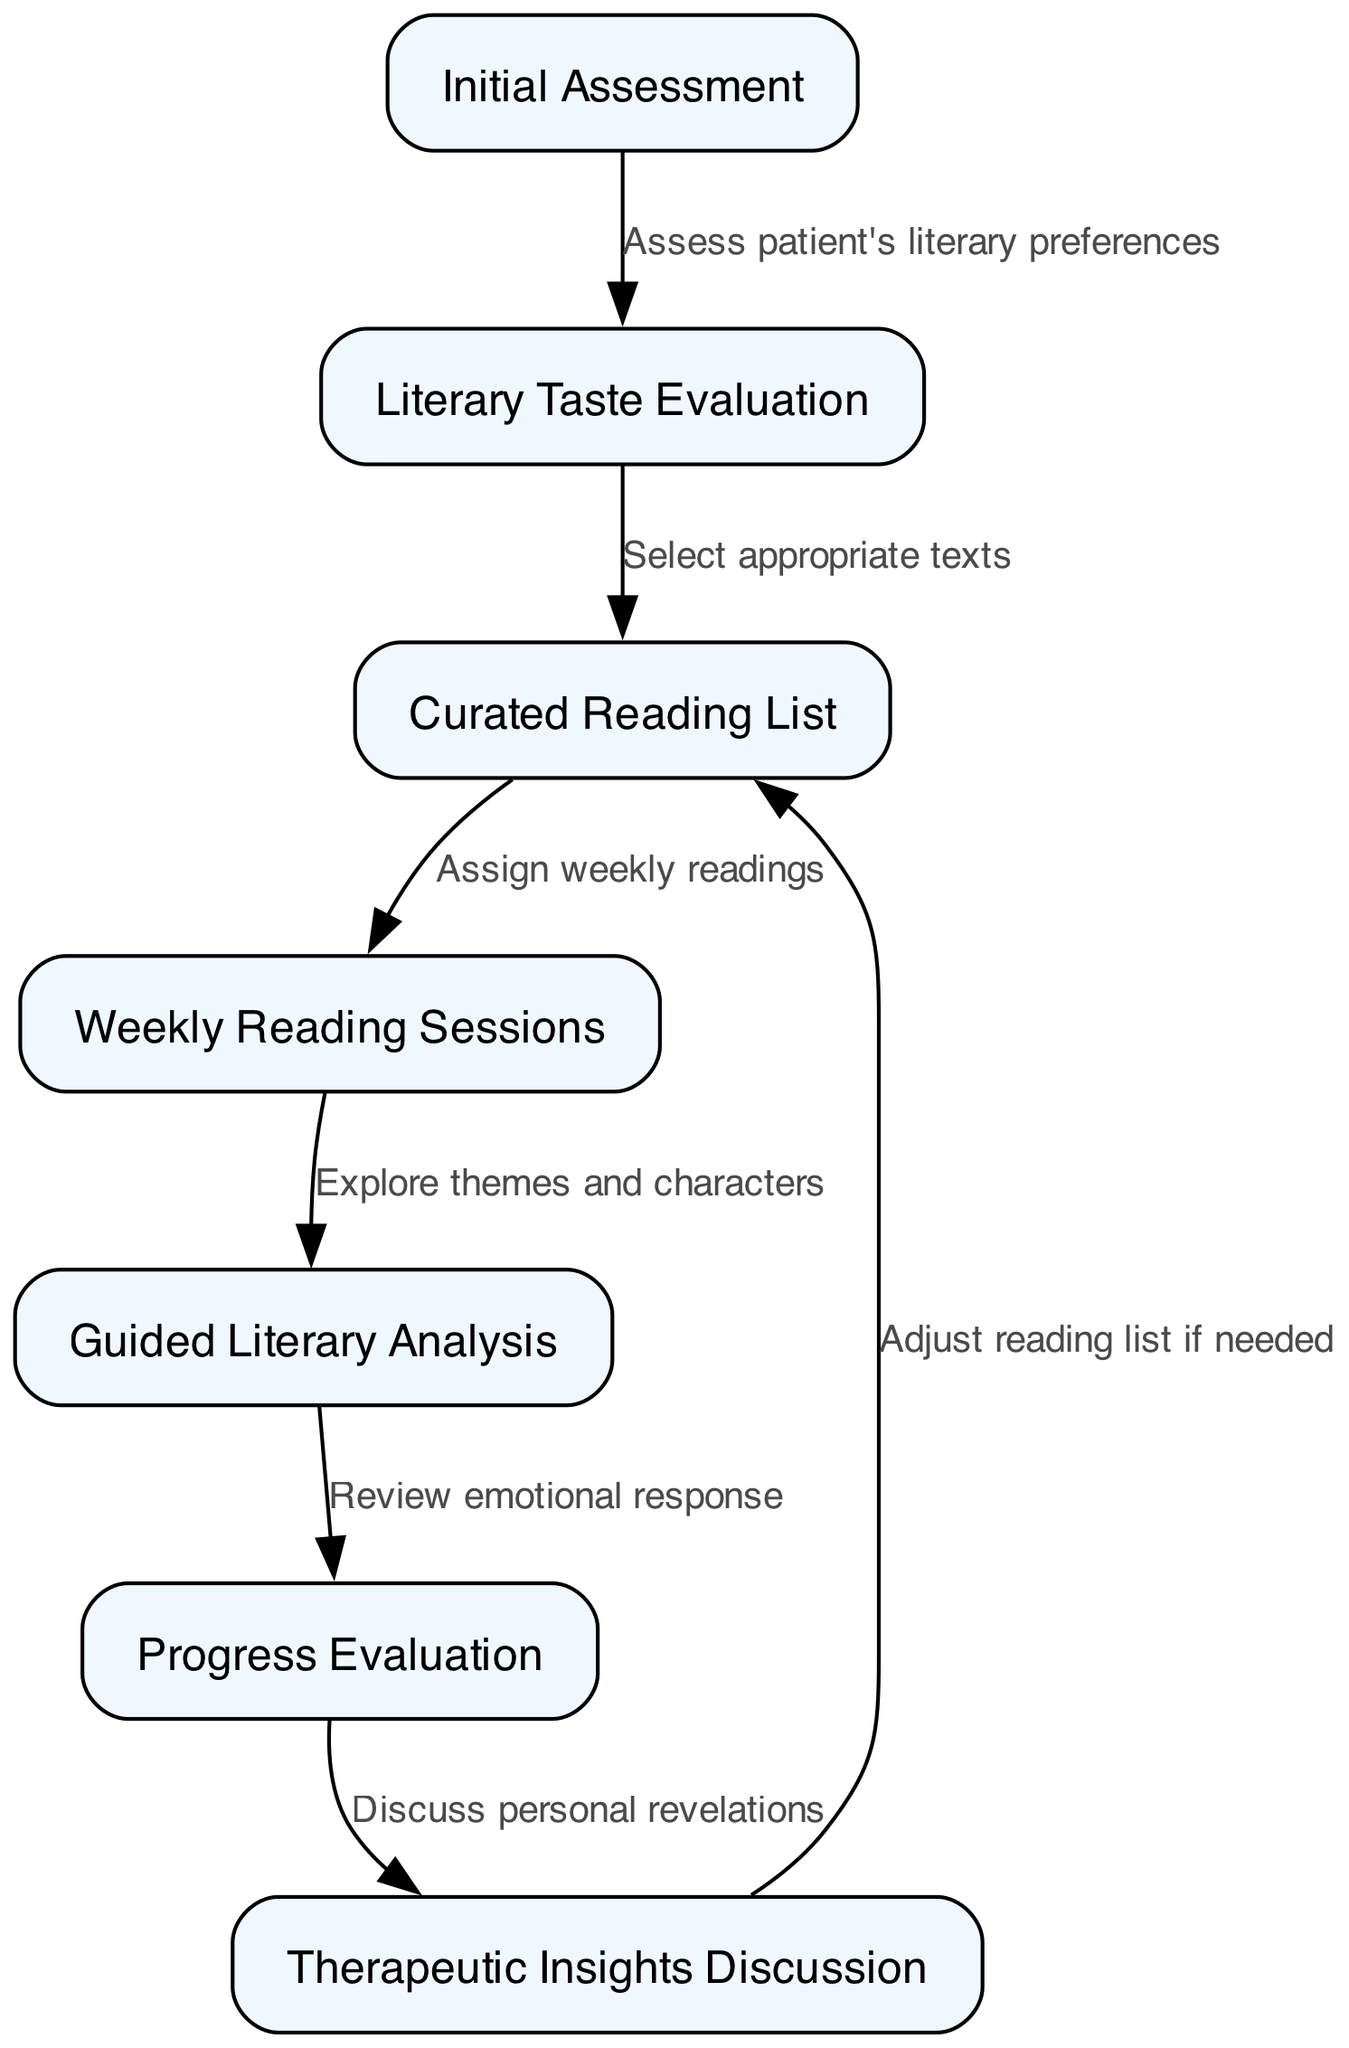What is the first step in the treatment pathway? The first step, as indicated by the initial node, is "Initial Assessment." This node initiates the treatment pathway process.
Answer: Initial Assessment How many nodes are there in the diagram? By counting all the distinct nodes in the diagram, seven nodes are identified: Initial Assessment, Literary Taste Evaluation, Curated Reading List, Weekly Reading Sessions, Guided Literary Analysis, Progress Evaluation, and Therapeutic Insights Discussion.
Answer: 7 What does the edge from "4" to "5" represent? The edge connecting node "4" (Weekly Reading Sessions) to node "5" (Guided Literary Analysis) signifies the transition of focus from reading to the exploration of themes and characters. It indicates that after reading, the next step is to analyze the literature more deeply.
Answer: Explore themes and characters What adjustment is made after the Therapeutic Insights Discussion? After the Therapeutic Insights Discussion, the pathway indicates that adjustments to the reading list may be necessary, reflecting that insights gained could lead to a change in reading materials.
Answer: Adjust reading list if needed Which two nodes are directly connected by the edge labeled "Select appropriate texts"? The edge labeled "Select appropriate texts" connects node "2" (Literary Taste Evaluation) and node "3" (Curated Reading List), indicating that after evaluating literary taste, the next step is to select the texts appropriate for the patient's preferences.
Answer: Literary Taste Evaluation and Curated Reading List What is the purpose of the node labeled "Progress Evaluation"? The node "Progress Evaluation" serves to review the emotional responses of the patients based on their readings and can help to assess the effectiveness of the bibliotherapy approach, as it is a critical reflection point in the treatment pathway.
Answer: Review emotional response What happens after the Weekly Reading Sessions? Following the Weekly Reading Sessions, the next step in the sequence is to engage in Guided Literary Analysis, where the focus shifts to a deeper analysis of the literature that has been read.
Answer: Guided Literary Analysis 